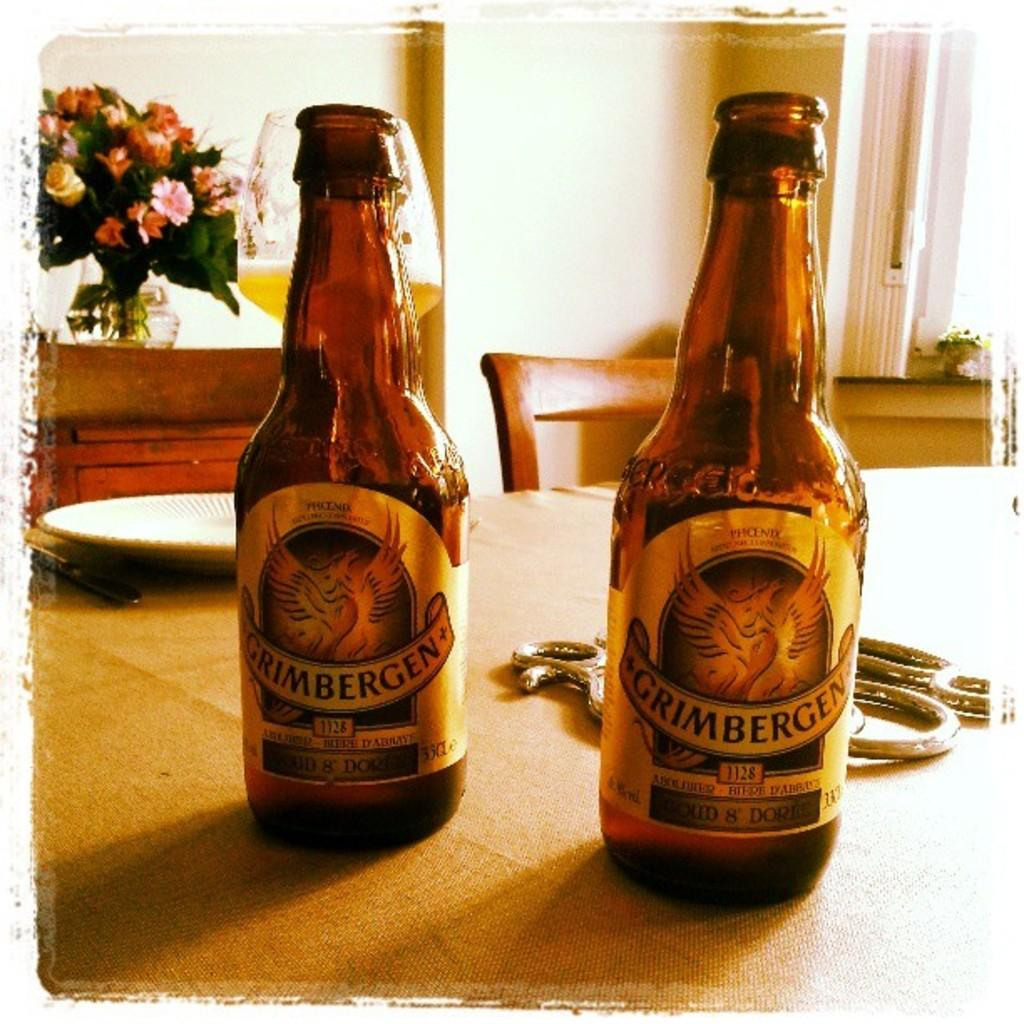<image>
Give a short and clear explanation of the subsequent image. Two bottles of Grimbergen siting on a table. 